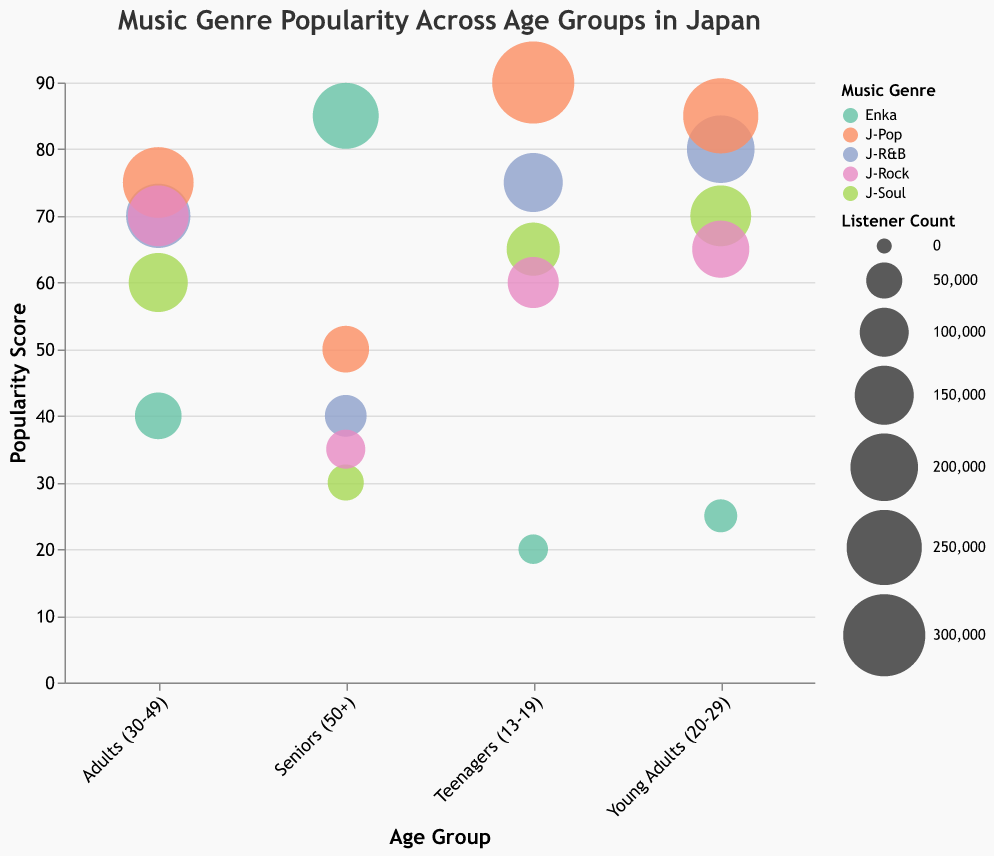What's the title of the chart? The title is usually displayed prominently at the top of the chart.
Answer: Music Genre Popularity Across Age Groups in Japan Which age group has the highest popularity score for J-R&B? The y-axis represents the popularity, and by checking the J-R&B points color-coded in the legend, we see the highest point on the popularity scale.
Answer: Young Adults (20-29) What is the listener count for J-Pop among Teenagers (13-19)? The tooltip or size of the bubble for J-Pop in the Teenagers age group will show the listener count.
Answer: 300,000 Which genre has the lowest popularity among Seniors (50+)? Refer to the bubbles in the Seniors age group and find the one with the lowest y-value (popularity).
Answer: J-Soul What is the difference in popularity between J-Pop and J-Rock among Adults (30-49)? Locate the J-Pop and J-Rock bubbles in the Adults age group, then subtract the popularity value of J-Rock from that of J-Pop.
Answer: 5 Among Young Adults (20-29), which genre has the largest bubble size and what does it represent? By looking at the bubble sizes for Young Adults, identify the largest bubble and refer to the legend to understand what the size indicates.
Answer: J-Pop, representing listener count of 250,000 How does Enka's popularity change from Teenagers (13-19) to Seniors (50+)? Observe the placement of Enka bubbles along the y-axis for the age groups from Teenagers to Seniors.
Answer: It increases from 20 to 85 Compare the popularity of J-Soul and J-R&B among Young Adults (20-29). Which one is more popular and by how much? Check the relative y-values of J-Soul and J-R&B bubbles in the Young Adults group, then calculate the difference.
Answer: J-R&B is more popular by 10 units What do the colors in the chart represent? The legend associated with the color attribute describes what the colors indicate on the chart.
Answer: Music Genre 